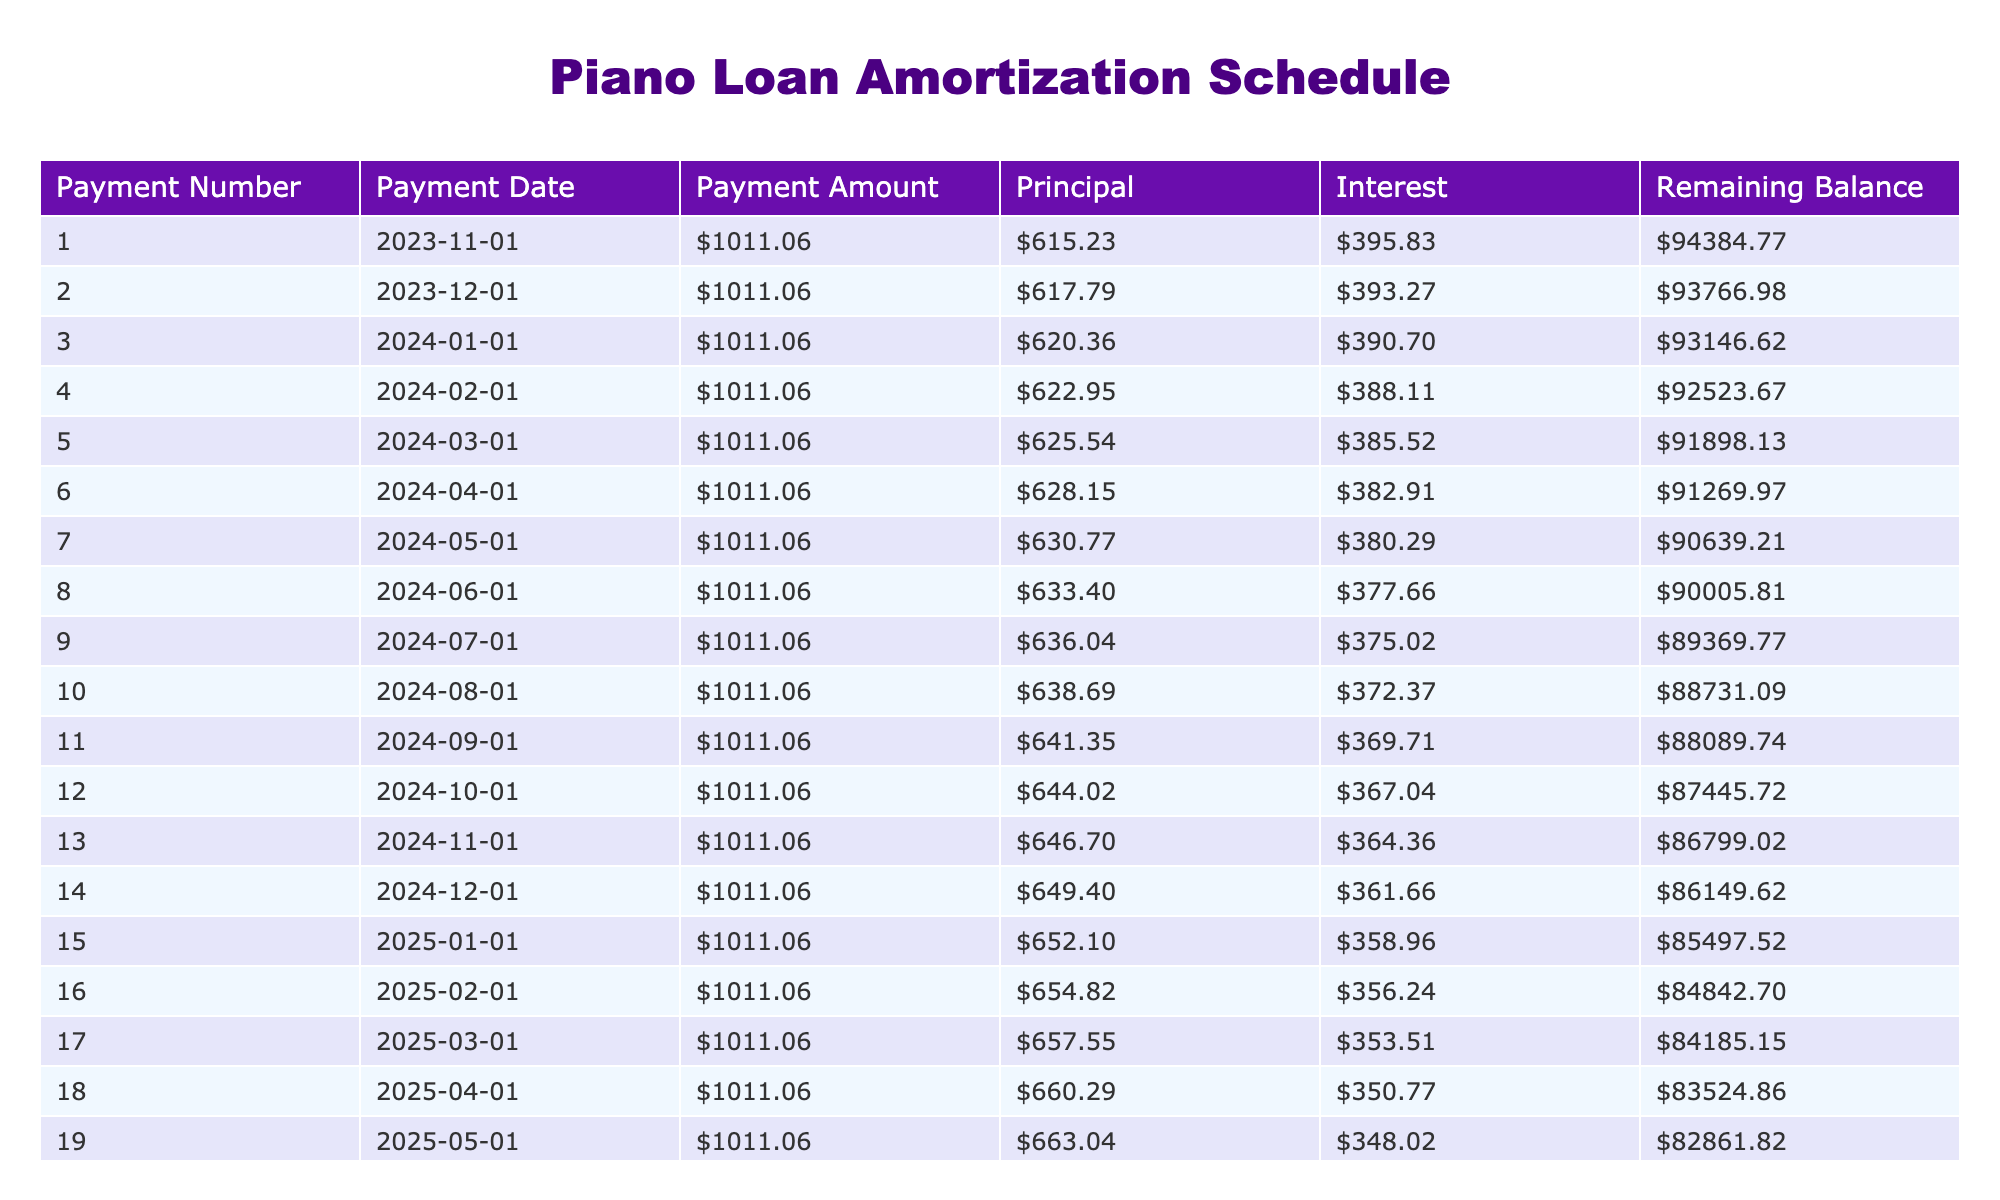What is the total amount paid over the loan term? The table shows that the Total Paid is listed as $121,327.20. This is a direct value found in the table without any calculations needed.
Answer: $121,327.20 What is the total interest paid on the loan? The Total Interest listed in the table is $26,327.20, which is also a direct value shown. Therefore, no calculations are needed to answer this.
Answer: $26,327.20 How much is the monthly payment? From the table, the Monthly Payment is given as $1,011.06. This information is directly retrieved from the table.
Answer: $1,011.06 What is the loan amount? The Loan Amount is specified in the table as $95,000. This is easily found without any calculations.
Answer: $95,000 What will be the remaining balance after the first payment? The Remaining Balance after the first payment will be calculated as follows: Remaining Balance = Loan Amount - Principal Payment. The Principal for the first payment can be derived as follows: Principal = Monthly Payment - Interest Payment (where Interest Payment is calculated as Loan Amount * Monthly Interest Rate, which is $95,000 * (5.0%/12)). The calculations show the Remaining Balance will be $95,000 - ($1,011.06 - $395.83) = $94,284.77
Answer: $94,284.77 Is the interest paid during the first month greater than $400? To find out if the interest is greater than $400, we first look at the Interest Payment for the first payment: Interest = Loan Amount * Monthly Interest Rate, which calculates to $95,000 * (5.0%/12) = $395.83. Since $395.83 is less than $400, we can conclude that it is false.
Answer: No How much total principal will be paid after the first year (12 payments)? To find the total principal paid after one year, we sum the Principal amounts for the first 12 payments. The first few principal payments can be derived from the table's data, and repeating this computation for all 12 payments gives a total of approximately $11,952.88. This is calculated based on entries for each monthly principal payment.
Answer: $11,952.88 After how many payments will the remaining balance be less than $80,000? To find out when the remaining balance drops below $80,000, we can evaluate the remaining balance after each payment and observe that it will drop below $80,000 after the 8th payment. This involves iterative calculations based on the remaining balance from each payment.
Answer: 8 payments What is the average monthly interest payment over the loan term? The average monthly interest payment is calculated by summing each monthly interest payment and dividing by the total number of payments (120 months). Individual monthly interest payments decrease with each payment, and averaging these through calculations gives an approximate average of $219.40. This requires summing up the individual monthly interest payments for accurate averaging.
Answer: $219.40 